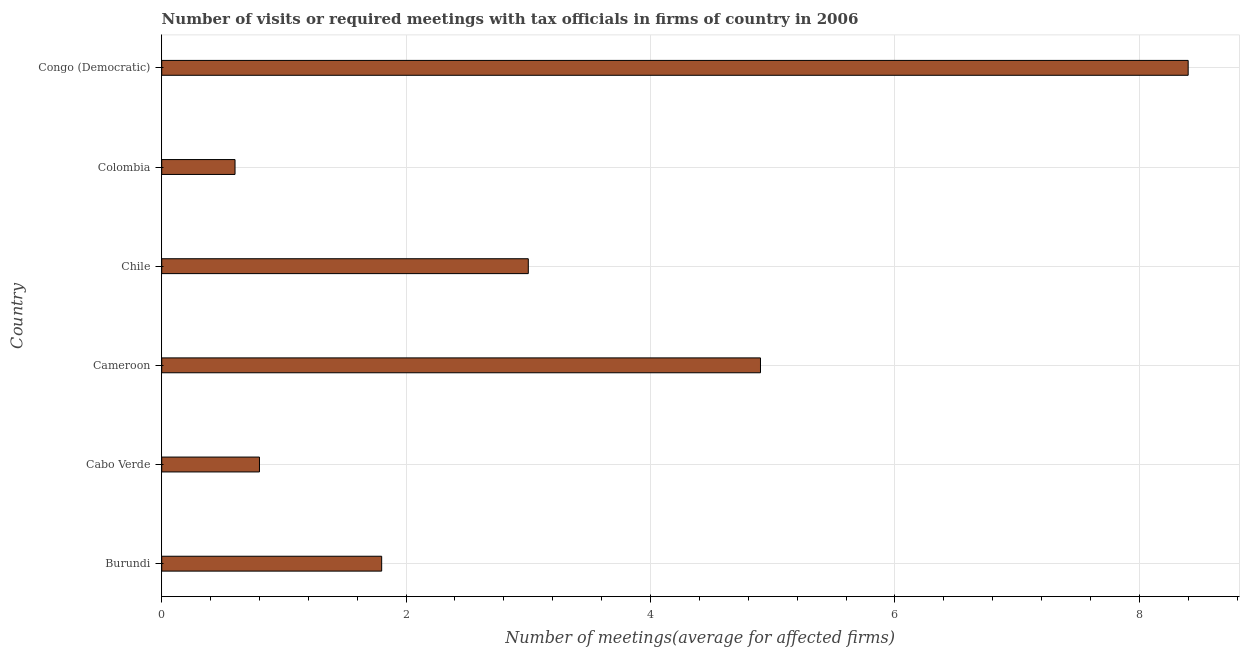Does the graph contain any zero values?
Give a very brief answer. No. What is the title of the graph?
Your answer should be very brief. Number of visits or required meetings with tax officials in firms of country in 2006. What is the label or title of the X-axis?
Offer a terse response. Number of meetings(average for affected firms). What is the label or title of the Y-axis?
Offer a very short reply. Country. What is the number of required meetings with tax officials in Chile?
Offer a terse response. 3. Across all countries, what is the maximum number of required meetings with tax officials?
Provide a short and direct response. 8.4. Across all countries, what is the minimum number of required meetings with tax officials?
Provide a short and direct response. 0.6. In which country was the number of required meetings with tax officials maximum?
Your response must be concise. Congo (Democratic). What is the difference between the number of required meetings with tax officials in Burundi and Congo (Democratic)?
Keep it short and to the point. -6.6. What is the average number of required meetings with tax officials per country?
Offer a very short reply. 3.25. What is the ratio of the number of required meetings with tax officials in Cabo Verde to that in Congo (Democratic)?
Give a very brief answer. 0.1. Is the number of required meetings with tax officials in Colombia less than that in Congo (Democratic)?
Provide a short and direct response. Yes. What is the difference between the highest and the second highest number of required meetings with tax officials?
Offer a very short reply. 3.5. What is the difference between the highest and the lowest number of required meetings with tax officials?
Provide a short and direct response. 7.8. How many bars are there?
Provide a succinct answer. 6. How many countries are there in the graph?
Give a very brief answer. 6. What is the difference between two consecutive major ticks on the X-axis?
Your answer should be very brief. 2. What is the Number of meetings(average for affected firms) of Burundi?
Your answer should be compact. 1.8. What is the Number of meetings(average for affected firms) in Cabo Verde?
Provide a short and direct response. 0.8. What is the Number of meetings(average for affected firms) in Chile?
Offer a very short reply. 3. What is the Number of meetings(average for affected firms) of Colombia?
Give a very brief answer. 0.6. What is the Number of meetings(average for affected firms) of Congo (Democratic)?
Make the answer very short. 8.4. What is the difference between the Number of meetings(average for affected firms) in Burundi and Cabo Verde?
Keep it short and to the point. 1. What is the difference between the Number of meetings(average for affected firms) in Burundi and Chile?
Provide a succinct answer. -1.2. What is the difference between the Number of meetings(average for affected firms) in Burundi and Colombia?
Offer a terse response. 1.2. What is the difference between the Number of meetings(average for affected firms) in Burundi and Congo (Democratic)?
Provide a succinct answer. -6.6. What is the difference between the Number of meetings(average for affected firms) in Cabo Verde and Cameroon?
Your answer should be compact. -4.1. What is the difference between the Number of meetings(average for affected firms) in Cabo Verde and Chile?
Your answer should be very brief. -2.2. What is the difference between the Number of meetings(average for affected firms) in Cabo Verde and Colombia?
Keep it short and to the point. 0.2. What is the difference between the Number of meetings(average for affected firms) in Cabo Verde and Congo (Democratic)?
Provide a short and direct response. -7.6. What is the difference between the Number of meetings(average for affected firms) in Cameroon and Colombia?
Offer a terse response. 4.3. What is the difference between the Number of meetings(average for affected firms) in Cameroon and Congo (Democratic)?
Provide a succinct answer. -3.5. What is the ratio of the Number of meetings(average for affected firms) in Burundi to that in Cabo Verde?
Provide a short and direct response. 2.25. What is the ratio of the Number of meetings(average for affected firms) in Burundi to that in Cameroon?
Your answer should be very brief. 0.37. What is the ratio of the Number of meetings(average for affected firms) in Burundi to that in Congo (Democratic)?
Offer a very short reply. 0.21. What is the ratio of the Number of meetings(average for affected firms) in Cabo Verde to that in Cameroon?
Offer a very short reply. 0.16. What is the ratio of the Number of meetings(average for affected firms) in Cabo Verde to that in Chile?
Make the answer very short. 0.27. What is the ratio of the Number of meetings(average for affected firms) in Cabo Verde to that in Colombia?
Ensure brevity in your answer.  1.33. What is the ratio of the Number of meetings(average for affected firms) in Cabo Verde to that in Congo (Democratic)?
Your response must be concise. 0.1. What is the ratio of the Number of meetings(average for affected firms) in Cameroon to that in Chile?
Provide a succinct answer. 1.63. What is the ratio of the Number of meetings(average for affected firms) in Cameroon to that in Colombia?
Your answer should be compact. 8.17. What is the ratio of the Number of meetings(average for affected firms) in Cameroon to that in Congo (Democratic)?
Keep it short and to the point. 0.58. What is the ratio of the Number of meetings(average for affected firms) in Chile to that in Congo (Democratic)?
Provide a short and direct response. 0.36. What is the ratio of the Number of meetings(average for affected firms) in Colombia to that in Congo (Democratic)?
Keep it short and to the point. 0.07. 